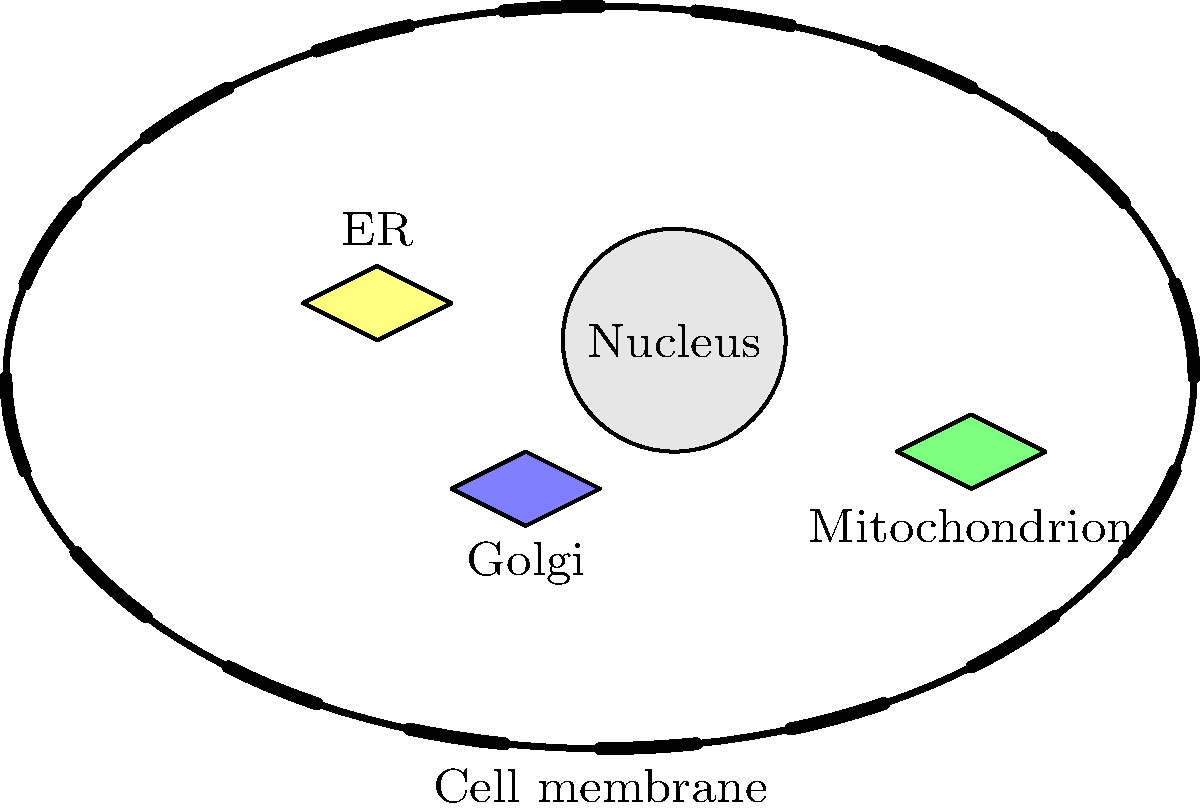In the labeled cell diagram, which organelle is responsible for packaging and distributing proteins within the cell? Explain its role in cellular function. To answer this question, let's follow these steps:

1. Observe the labeled diagram carefully.
2. Identify the organelle responsible for packaging and distributing proteins.
3. Understand its role in cellular function.

Step 1: The diagram shows several key organelles in a eukaryotic cell, including the nucleus, mitochondrion, endoplasmic reticulum (ER), and Golgi apparatus.

Step 2: The Golgi apparatus, labeled as "Golgi" in the diagram, is the organelle responsible for packaging and distributing proteins within the cell.

Step 3: The Golgi apparatus plays a crucial role in cellular function:
   a) It receives proteins and lipids from the endoplasmic reticulum.
   b) It modifies these molecules by adding carbohydrates or phosphates.
   c) It sorts and packages the modified proteins into vesicles.
   d) These vesicles then transport the proteins to their final destinations, either within the cell or for secretion outside the cell.

The Golgi apparatus acts as the cell's post office, receiving, processing, and sending out cellular products to where they're needed.
Answer: Golgi apparatus 